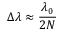<formula> <loc_0><loc_0><loc_500><loc_500>\Delta \lambda \approx \frac { \lambda _ { 0 } } { 2 N }</formula> 